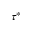Convert formula to latex. <formula><loc_0><loc_0><loc_500><loc_500>\tau ^ { * }</formula> 